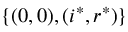<formula> <loc_0><loc_0><loc_500><loc_500>\{ ( 0 , 0 ) , ( i ^ { * } , r ^ { * } ) \}</formula> 